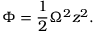Convert formula to latex. <formula><loc_0><loc_0><loc_500><loc_500>\Phi = \frac { 1 } { 2 } \Omega ^ { 2 } z ^ { 2 } .</formula> 